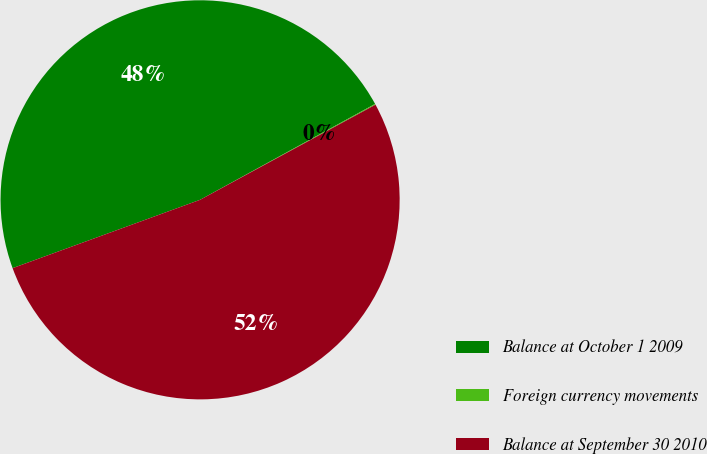<chart> <loc_0><loc_0><loc_500><loc_500><pie_chart><fcel>Balance at October 1 2009<fcel>Foreign currency movements<fcel>Balance at September 30 2010<nl><fcel>47.58%<fcel>0.07%<fcel>52.34%<nl></chart> 